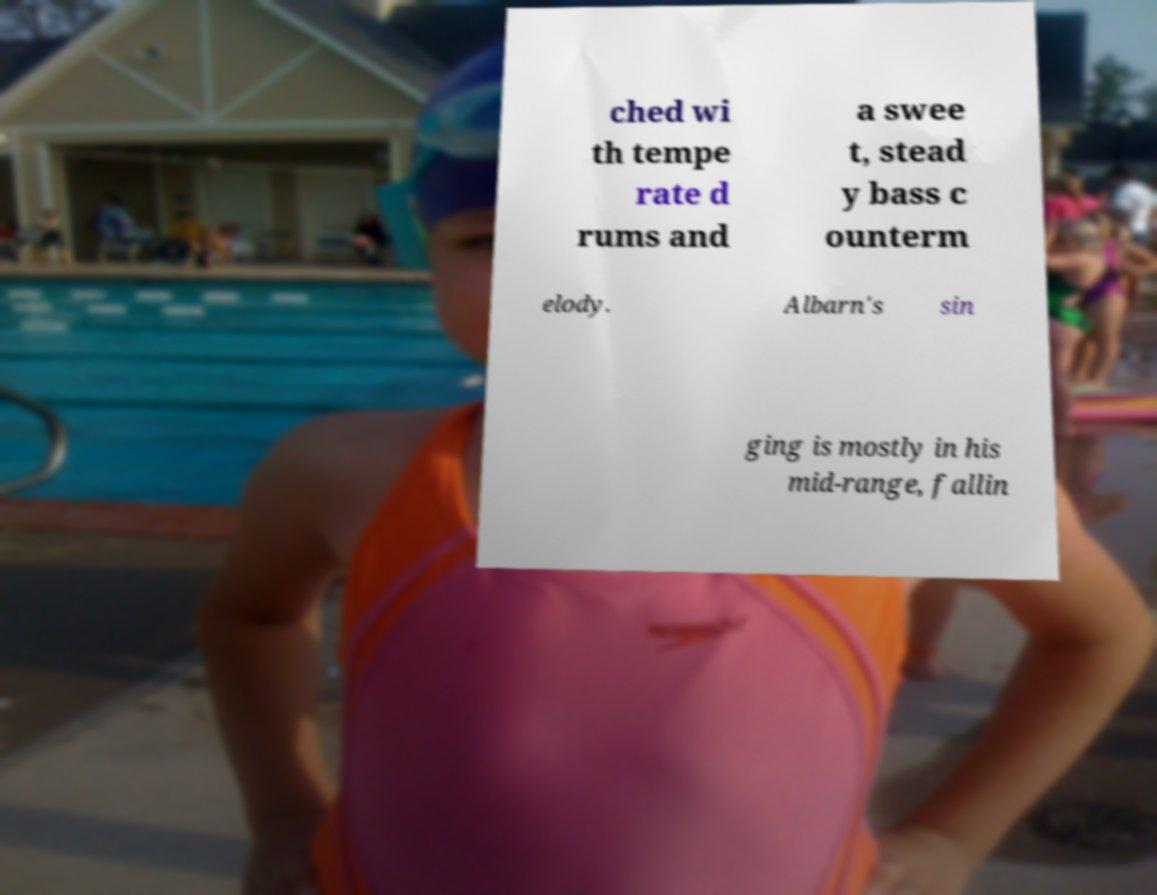Please read and relay the text visible in this image. What does it say? ched wi th tempe rate d rums and a swee t, stead y bass c ounterm elody. Albarn's sin ging is mostly in his mid-range, fallin 